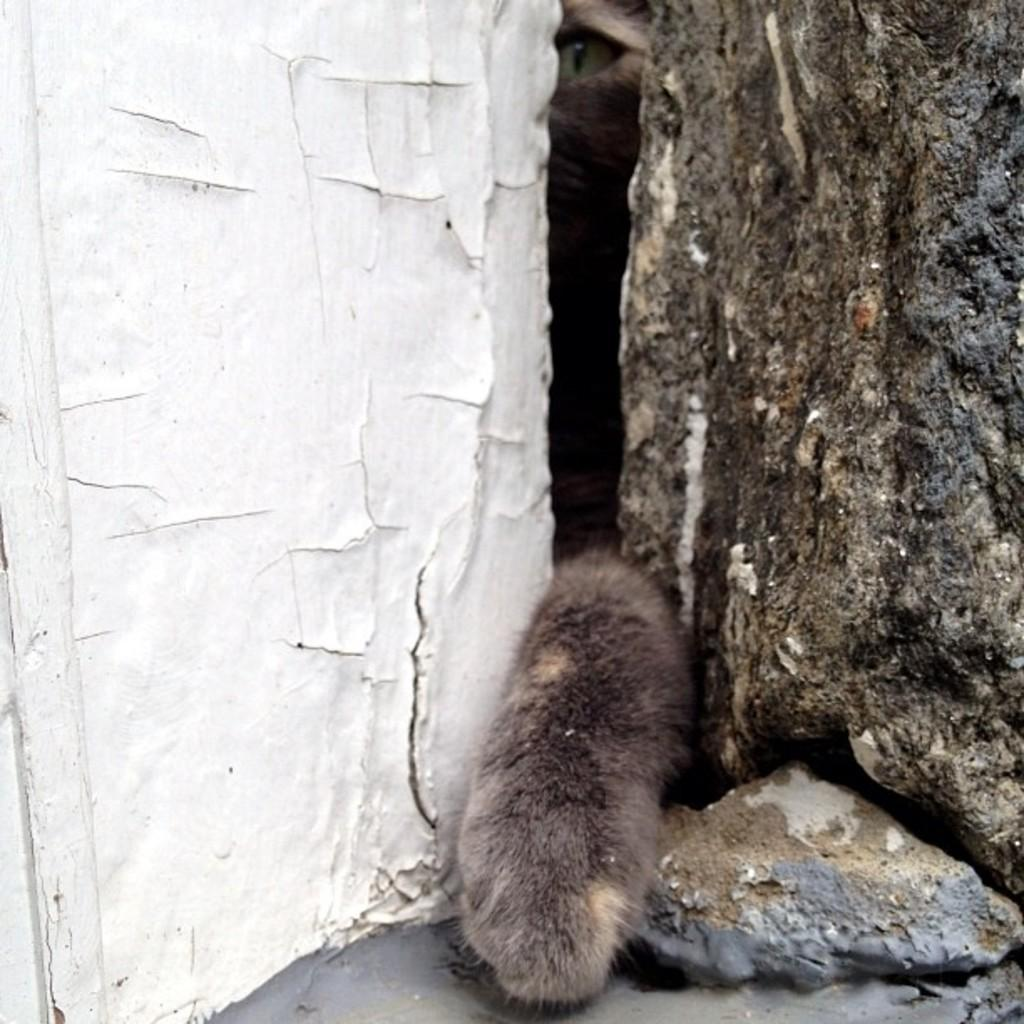What type of structure can be seen in the image? There are walls in the image. Can you describe the opening in between the walls? There is a small opening in between the walls. What part of an animal is visible in the image? There is a tail of an animal and an eye of an animal at the top of the image. What type of dress is the animal wearing in the image? There is no animal wearing a dress in the image; the animal parts visible are the tail and the eye. 